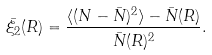Convert formula to latex. <formula><loc_0><loc_0><loc_500><loc_500>\bar { \xi _ { 2 } } ( R ) = \frac { \langle ( N - \bar { N } ) ^ { 2 } \rangle - \bar { N } ( R ) } { \bar { N } ( R ) ^ { 2 } } .</formula> 